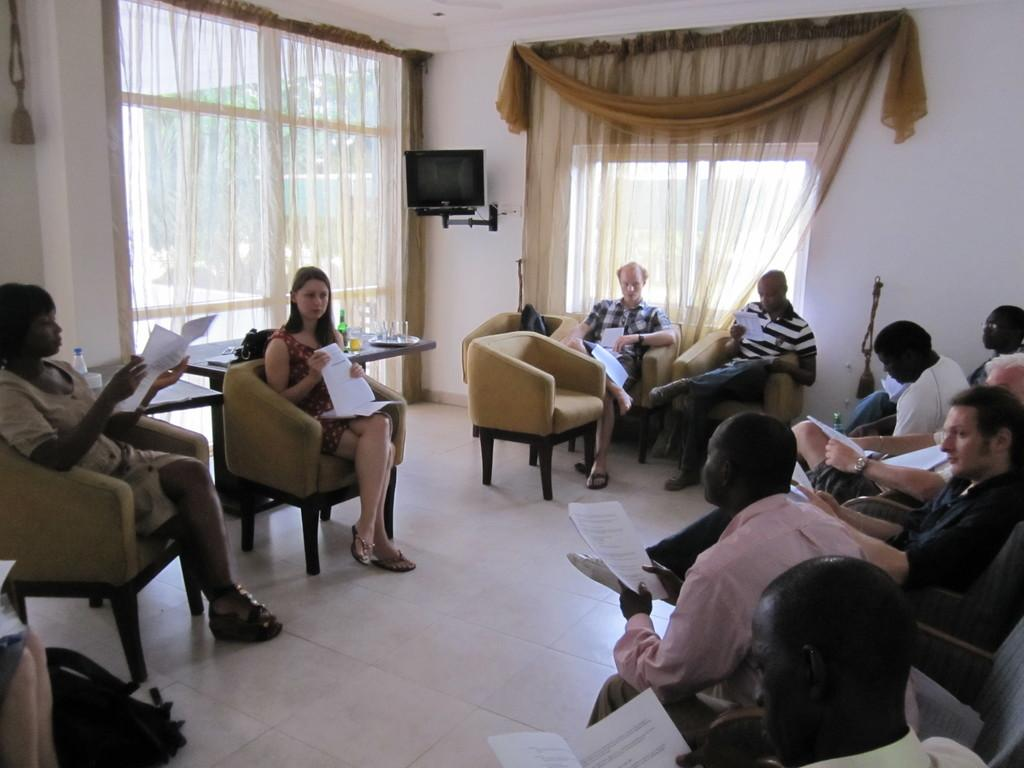What is happening in the image involving a group of people? There is a group of people in the image, and they are sitting on a chair or around a chair. What are the people holding in the image? The people are holding papers in the image. What electronic device can be seen in the image? There is a TV in the image. What type of window treatment is present in the image? There are curtains in the image. What color is the wall behind the people in the image? There is a white wall in the image. How many dimes are placed on the TV in the image? There are no dimes present on the TV in the image. What type of spade is being used by the people in the image? There is no spade visible in the image; the people are holding papers. 